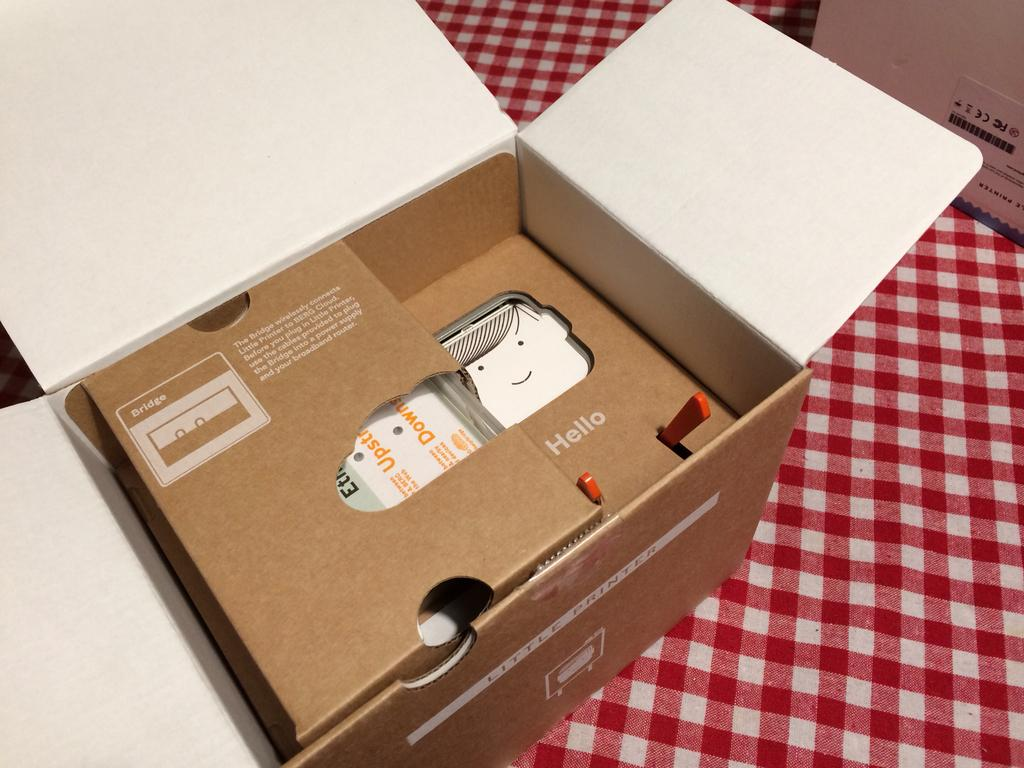Provide a one-sentence caption for the provided image. A box for Little Printer is opened and is resting on a kitchen table. 